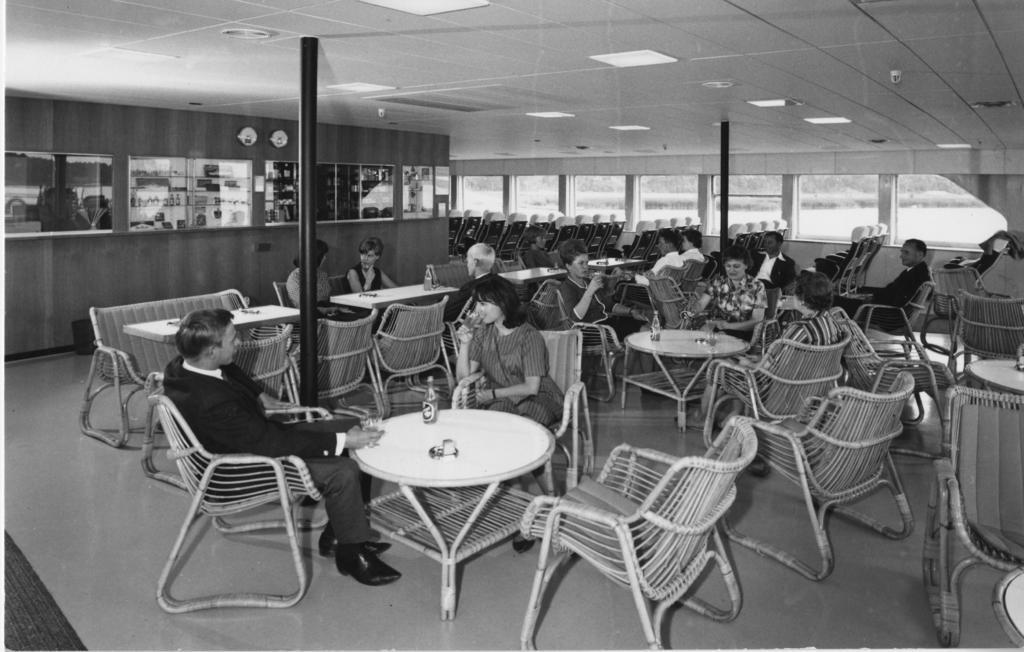Could you give a brief overview of what you see in this image? here in this picture we can see many tables and chairs present in the room,where we can see persons sitting in the chair and having food items which are present on the table,here we can see some bottles on the table. 